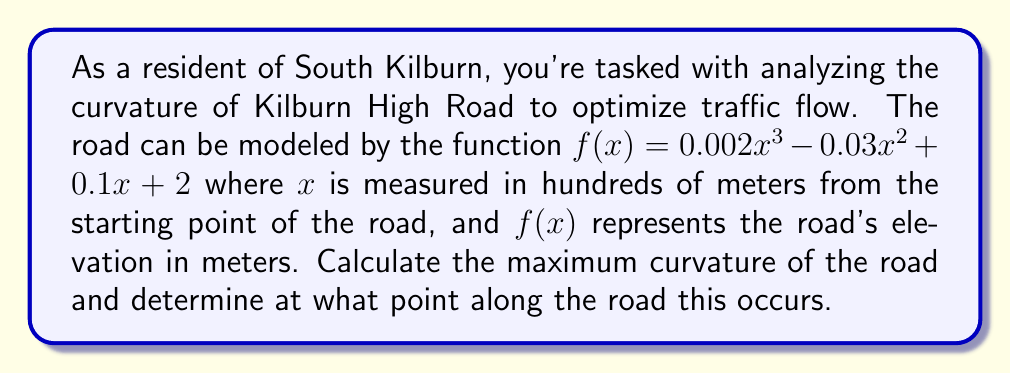Teach me how to tackle this problem. To solve this problem, we'll follow these steps:

1) The curvature of a function $f(x)$ is given by the formula:

   $$\kappa = \frac{|f''(x)|}{(1 + (f'(x))^2)^{3/2}}$$

2) First, let's find $f'(x)$ and $f''(x)$:
   
   $f'(x) = 0.006x^2 - 0.06x + 0.1$
   $f''(x) = 0.012x - 0.06$

3) Now, we can substitute these into our curvature formula:

   $$\kappa = \frac{|0.012x - 0.06|}{(1 + (0.006x^2 - 0.06x + 0.1)^2)^{3/2}}$$

4) To find the maximum curvature, we need to find where the derivative of $\kappa$ with respect to $x$ is zero. However, this leads to a complex equation that's difficult to solve analytically.

5) Instead, we can use the fact that for this cubic function, the point of maximum curvature will occur at the inflection point, where $f''(x) = 0$.

6) Solving $0.012x - 0.06 = 0$:
   
   $x = 5$

7) This means the maximum curvature occurs 500 meters from the starting point.

8) To find the maximum curvature value, we substitute $x = 5$ into our curvature formula:

   $$\kappa_{max} = \frac{|0.012(5) - 0.06|}{(1 + (0.006(5)^2 - 0.06(5) + 0.1)^2)^{3/2}}$$

   $$= \frac{0}{(1 + 0.1^2)^{3/2}} = 0$$

9) The curvature at this point is actually zero because it's an inflection point. The maximum non-zero curvature would occur slightly before or after this point.
Answer: The maximum curvature of Kilburn High Road occurs 500 meters from the starting point. At this location, the curvature is actually zero as it's an inflection point. The maximum non-zero curvature would be found slightly before or after this point. 